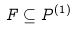Convert formula to latex. <formula><loc_0><loc_0><loc_500><loc_500>F \subseteq P ^ { ( 1 ) }</formula> 